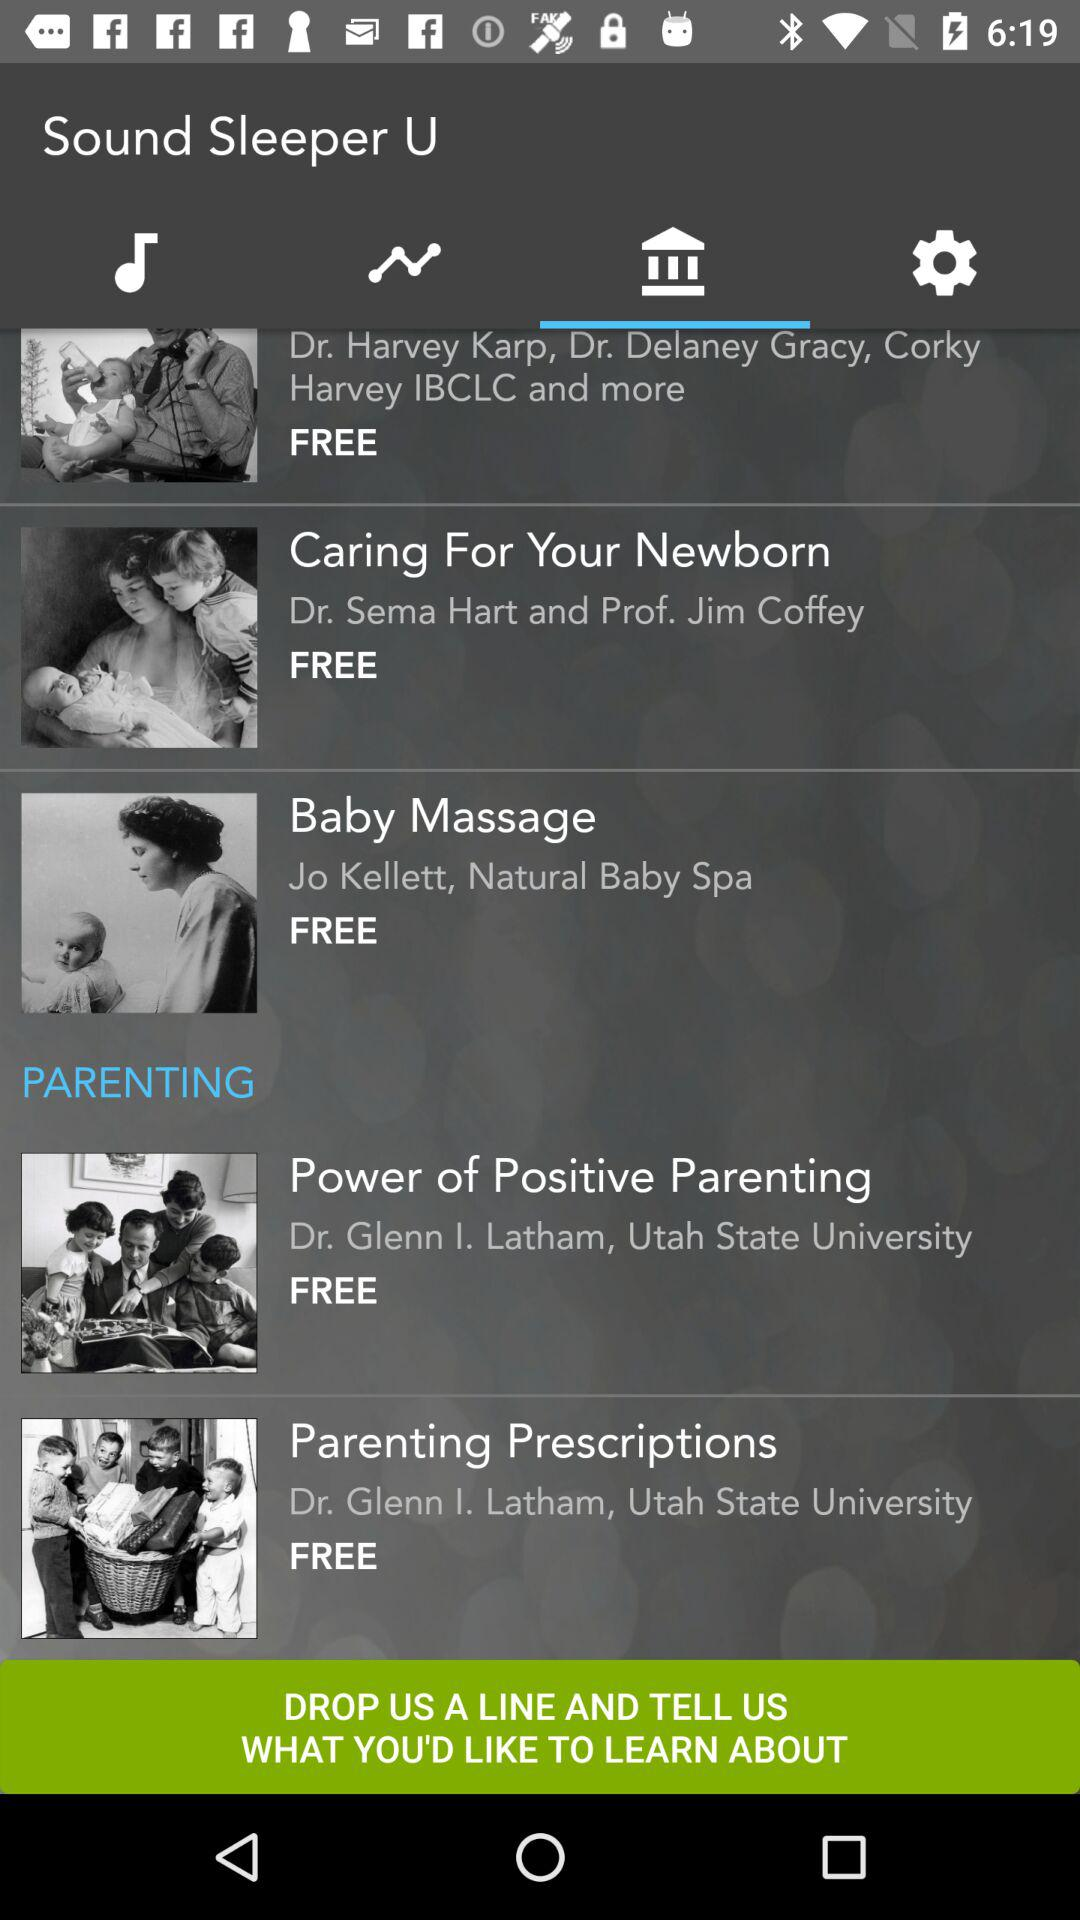What is the application name? The application name is "Sound Sleeper U". 